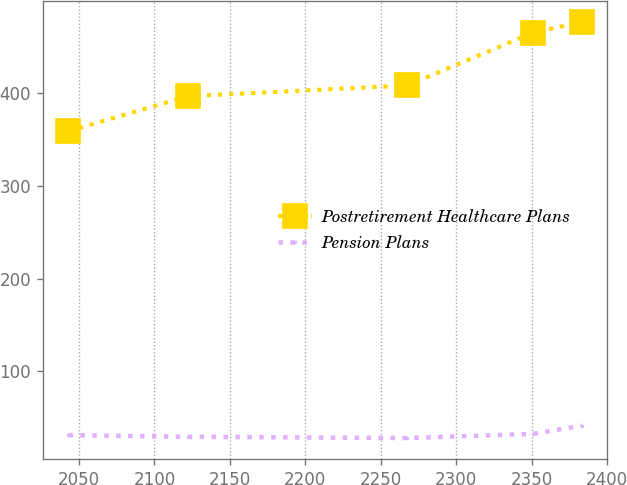Convert chart to OTSL. <chart><loc_0><loc_0><loc_500><loc_500><line_chart><ecel><fcel>Postretirement Healthcare Plans<fcel>Pension Plans<nl><fcel>2043.06<fcel>359.01<fcel>31.3<nl><fcel>2122.12<fcel>396.68<fcel>29.51<nl><fcel>2267.42<fcel>408.26<fcel>28.17<nl><fcel>2350.67<fcel>465.1<fcel>32.63<nl><fcel>2383.09<fcel>476.68<fcel>41.52<nl></chart> 